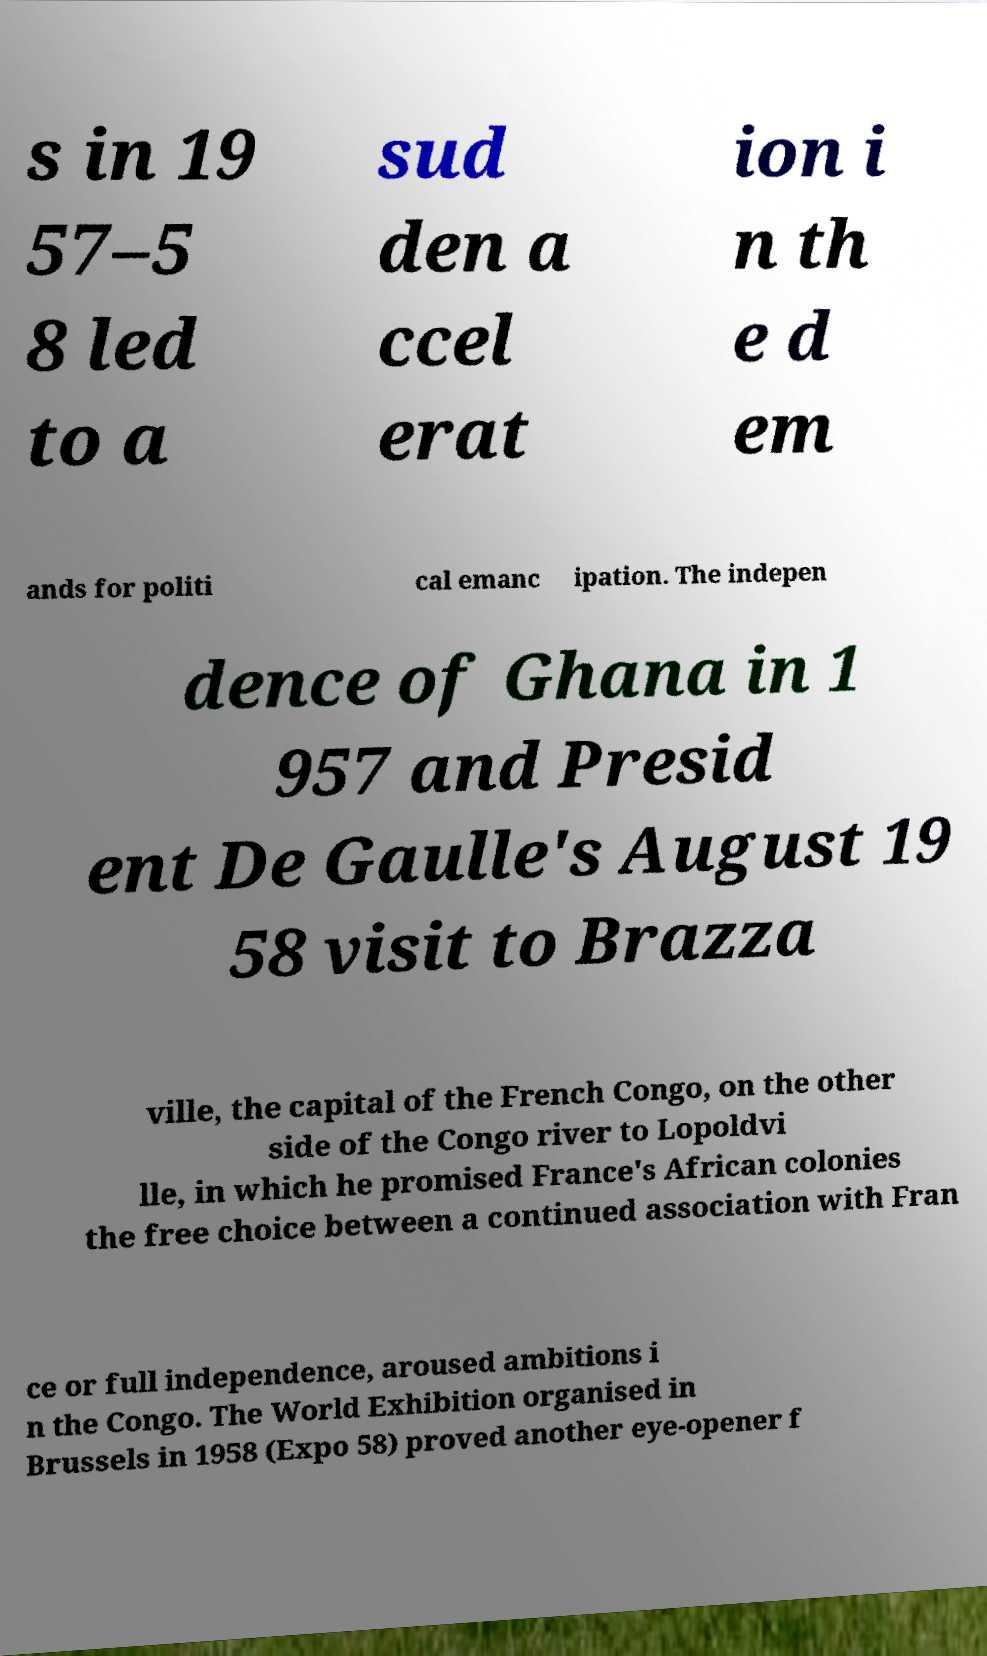There's text embedded in this image that I need extracted. Can you transcribe it verbatim? s in 19 57–5 8 led to a sud den a ccel erat ion i n th e d em ands for politi cal emanc ipation. The indepen dence of Ghana in 1 957 and Presid ent De Gaulle's August 19 58 visit to Brazza ville, the capital of the French Congo, on the other side of the Congo river to Lopoldvi lle, in which he promised France's African colonies the free choice between a continued association with Fran ce or full independence, aroused ambitions i n the Congo. The World Exhibition organised in Brussels in 1958 (Expo 58) proved another eye-opener f 